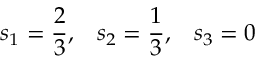Convert formula to latex. <formula><loc_0><loc_0><loc_500><loc_500>s _ { 1 } = \frac { 2 } { 3 } , \, s _ { 2 } = \frac { 1 } { 3 } , \, s _ { 3 } = 0</formula> 